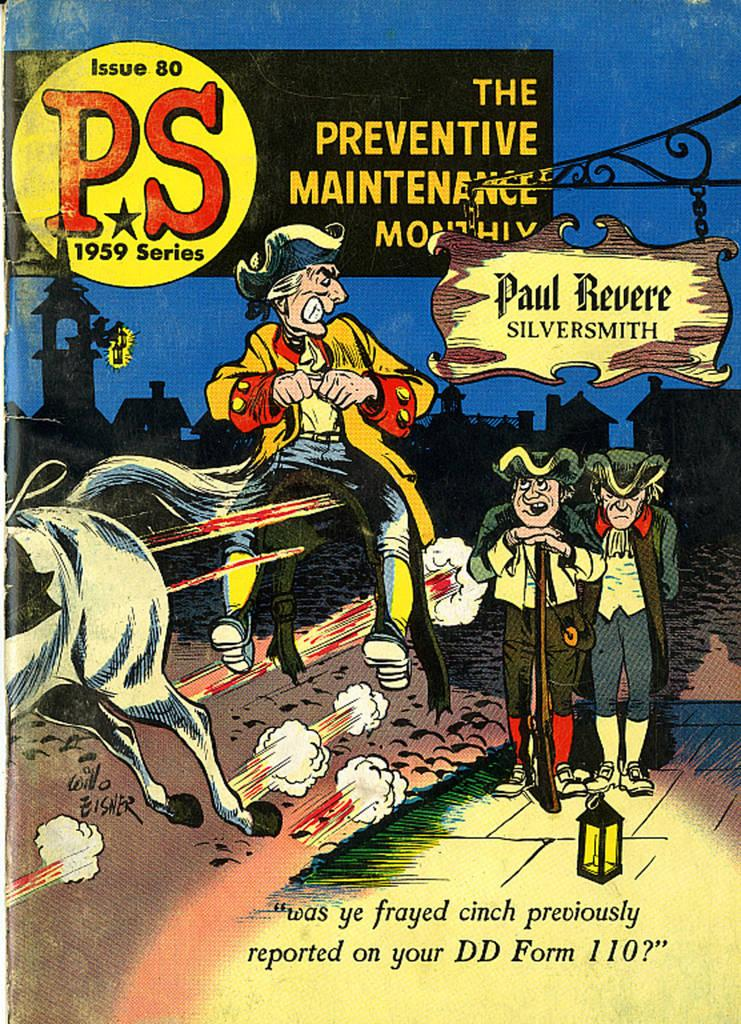<image>
Describe the image concisely. Ad showing three cartoon characters in front of a sign that says Paul Revere. 